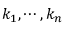Convert formula to latex. <formula><loc_0><loc_0><loc_500><loc_500>k _ { 1 } , \cdots , k _ { n }</formula> 